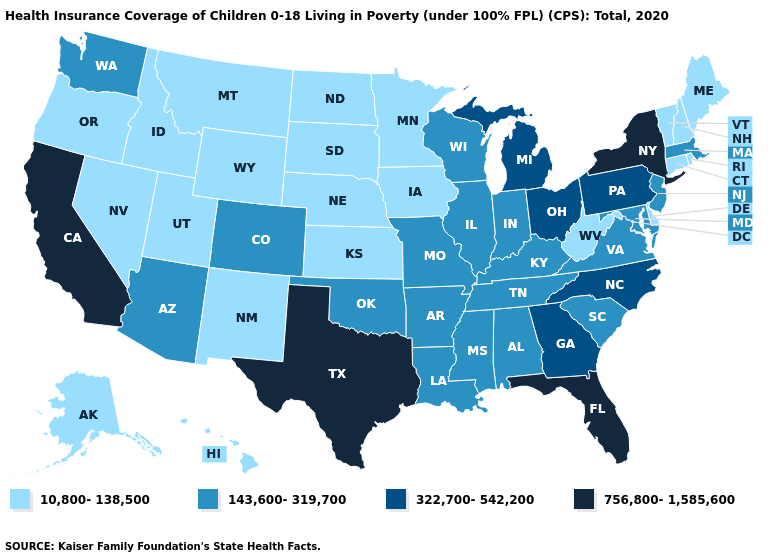Among the states that border South Carolina , which have the lowest value?
Write a very short answer. Georgia, North Carolina. Does Minnesota have the same value as California?
Write a very short answer. No. What is the value of Colorado?
Quick response, please. 143,600-319,700. What is the value of Oregon?
Give a very brief answer. 10,800-138,500. What is the value of Utah?
Keep it brief. 10,800-138,500. Does South Dakota have the highest value in the MidWest?
Keep it brief. No. Name the states that have a value in the range 143,600-319,700?
Quick response, please. Alabama, Arizona, Arkansas, Colorado, Illinois, Indiana, Kentucky, Louisiana, Maryland, Massachusetts, Mississippi, Missouri, New Jersey, Oklahoma, South Carolina, Tennessee, Virginia, Washington, Wisconsin. What is the value of Illinois?
Answer briefly. 143,600-319,700. Name the states that have a value in the range 756,800-1,585,600?
Concise answer only. California, Florida, New York, Texas. Does North Carolina have a lower value than New York?
Short answer required. Yes. What is the lowest value in the USA?
Quick response, please. 10,800-138,500. What is the value of North Dakota?
Be succinct. 10,800-138,500. How many symbols are there in the legend?
Write a very short answer. 4. Which states have the lowest value in the USA?
Be succinct. Alaska, Connecticut, Delaware, Hawaii, Idaho, Iowa, Kansas, Maine, Minnesota, Montana, Nebraska, Nevada, New Hampshire, New Mexico, North Dakota, Oregon, Rhode Island, South Dakota, Utah, Vermont, West Virginia, Wyoming. What is the value of Maine?
Give a very brief answer. 10,800-138,500. 